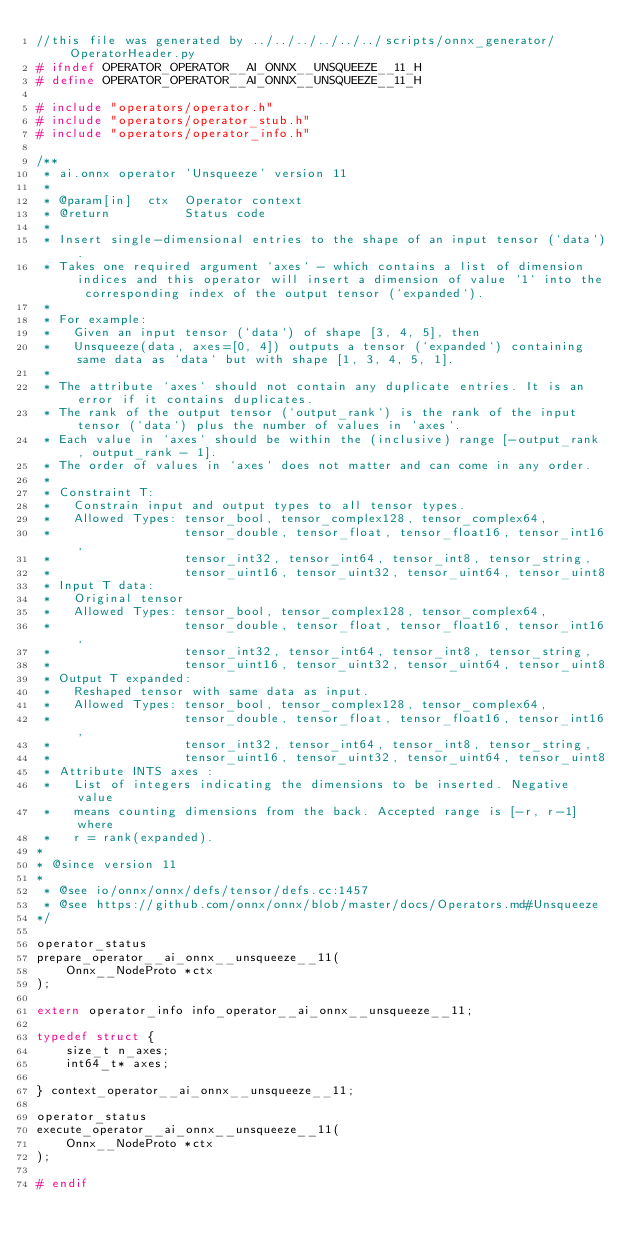Convert code to text. <code><loc_0><loc_0><loc_500><loc_500><_C_>//this file was generated by ../../../../../../scripts/onnx_generator/OperatorHeader.py
# ifndef OPERATOR_OPERATOR__AI_ONNX__UNSQUEEZE__11_H
# define OPERATOR_OPERATOR__AI_ONNX__UNSQUEEZE__11_H

# include "operators/operator.h"
# include "operators/operator_stub.h"
# include "operators/operator_info.h"

/**
 * ai.onnx operator 'Unsqueeze' version 11
 *
 * @param[in]  ctx  Operator context
 * @return          Status code
 *
 * Insert single-dimensional entries to the shape of an input tensor (`data`).
 * Takes one required argument `axes` - which contains a list of dimension indices and this operator will insert a dimension of value `1` into the corresponding index of the output tensor (`expanded`).
 * 
 * For example:
 *   Given an input tensor (`data`) of shape [3, 4, 5], then
 *   Unsqueeze(data, axes=[0, 4]) outputs a tensor (`expanded`) containing same data as `data` but with shape [1, 3, 4, 5, 1].
 * 
 * The attribute `axes` should not contain any duplicate entries. It is an error if it contains duplicates.
 * The rank of the output tensor (`output_rank`) is the rank of the input tensor (`data`) plus the number of values in `axes`.
 * Each value in `axes` should be within the (inclusive) range [-output_rank , output_rank - 1]. 
 * The order of values in `axes` does not matter and can come in any order.
 * 
 * Constraint T:
 *   Constrain input and output types to all tensor types.
 *   Allowed Types: tensor_bool, tensor_complex128, tensor_complex64,
 *                  tensor_double, tensor_float, tensor_float16, tensor_int16,
 *                  tensor_int32, tensor_int64, tensor_int8, tensor_string,
 *                  tensor_uint16, tensor_uint32, tensor_uint64, tensor_uint8
 * Input T data:
 *   Original tensor
 *   Allowed Types: tensor_bool, tensor_complex128, tensor_complex64,
 *                  tensor_double, tensor_float, tensor_float16, tensor_int16,
 *                  tensor_int32, tensor_int64, tensor_int8, tensor_string,
 *                  tensor_uint16, tensor_uint32, tensor_uint64, tensor_uint8
 * Output T expanded:
 *   Reshaped tensor with same data as input.
 *   Allowed Types: tensor_bool, tensor_complex128, tensor_complex64,
 *                  tensor_double, tensor_float, tensor_float16, tensor_int16,
 *                  tensor_int32, tensor_int64, tensor_int8, tensor_string,
 *                  tensor_uint16, tensor_uint32, tensor_uint64, tensor_uint8
 * Attribute INTS axes :
 *   List of integers indicating the dimensions to be inserted. Negative value
 *   means counting dimensions from the back. Accepted range is [-r, r-1] where
 *   r = rank(expanded).
*
* @since version 11
*
 * @see io/onnx/onnx/defs/tensor/defs.cc:1457
 * @see https://github.com/onnx/onnx/blob/master/docs/Operators.md#Unsqueeze
*/

operator_status
prepare_operator__ai_onnx__unsqueeze__11(
    Onnx__NodeProto *ctx
);

extern operator_info info_operator__ai_onnx__unsqueeze__11;

typedef struct {
    size_t n_axes;
    int64_t* axes;

} context_operator__ai_onnx__unsqueeze__11;

operator_status
execute_operator__ai_onnx__unsqueeze__11(
    Onnx__NodeProto *ctx
);

# endif</code> 